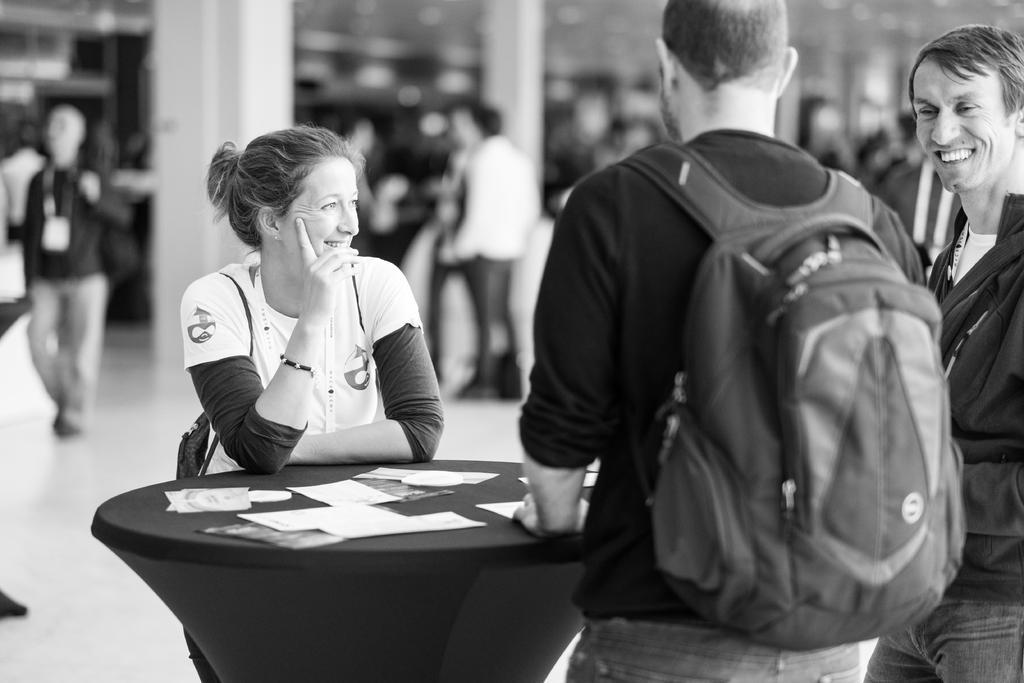In one or two sentences, can you explain what this image depicts? This looks like a black and white image. There are three persons standing. one person is wearing a backpack bag. This looks like a table with papers on it. At background I can see few people walking. 